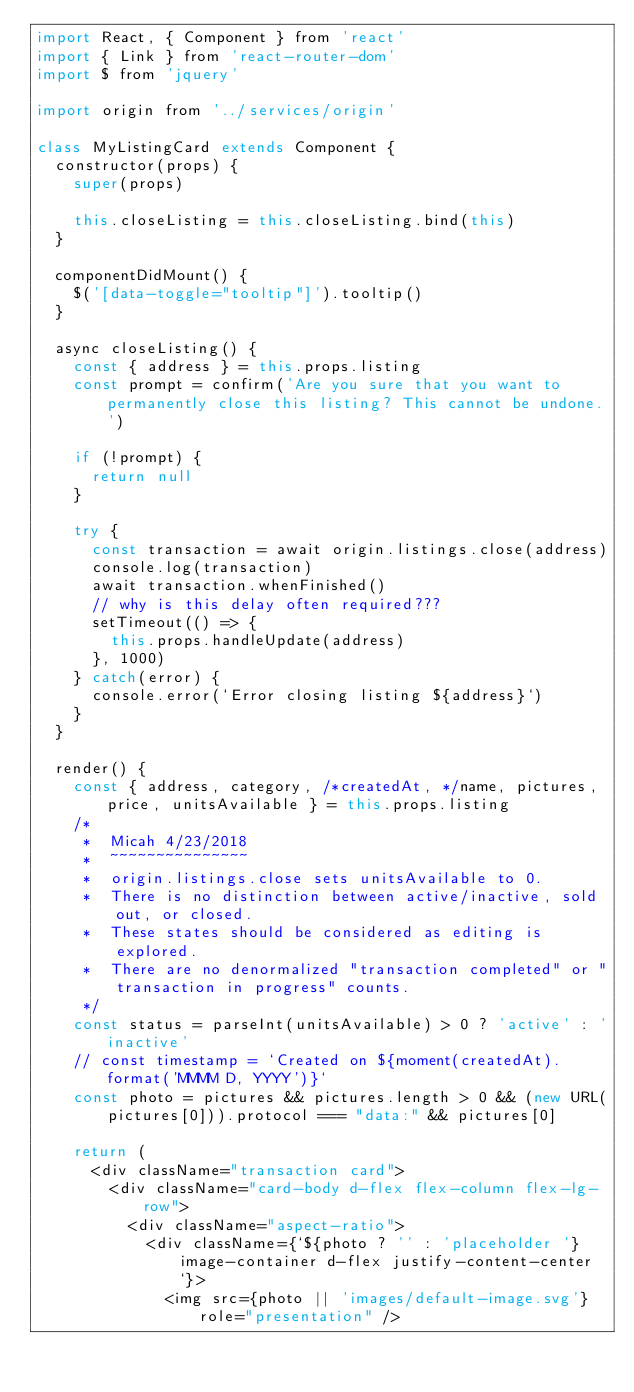Convert code to text. <code><loc_0><loc_0><loc_500><loc_500><_JavaScript_>import React, { Component } from 'react'
import { Link } from 'react-router-dom'
import $ from 'jquery'

import origin from '../services/origin'

class MyListingCard extends Component {
  constructor(props) {
    super(props)

    this.closeListing = this.closeListing.bind(this)
  }

  componentDidMount() {
    $('[data-toggle="tooltip"]').tooltip()
  }

  async closeListing() {
    const { address } = this.props.listing
    const prompt = confirm('Are you sure that you want to permanently close this listing? This cannot be undone.')

    if (!prompt) {
      return null
    }

    try {
      const transaction = await origin.listings.close(address)
      console.log(transaction)
      await transaction.whenFinished()
      // why is this delay often required???
      setTimeout(() => {
        this.props.handleUpdate(address)
      }, 1000)
    } catch(error) {
      console.error(`Error closing listing ${address}`)
    }
  }

  render() {
    const { address, category, /*createdAt, */name, pictures, price, unitsAvailable } = this.props.listing
    /*
     *  Micah 4/23/2018
     *  ~~~~~~~~~~~~~~~
     *  origin.listings.close sets unitsAvailable to 0.
     *  There is no distinction between active/inactive, sold out, or closed.
     *  These states should be considered as editing is explored.
     *  There are no denormalized "transaction completed" or "transaction in progress" counts.
     */
    const status = parseInt(unitsAvailable) > 0 ? 'active' : 'inactive'
    // const timestamp = `Created on ${moment(createdAt).format('MMMM D, YYYY')}`
    const photo = pictures && pictures.length > 0 && (new URL(pictures[0])).protocol === "data:" && pictures[0]

    return (
      <div className="transaction card">
        <div className="card-body d-flex flex-column flex-lg-row">
          <div className="aspect-ratio">
            <div className={`${photo ? '' : 'placeholder '}image-container d-flex justify-content-center`}>
              <img src={photo || 'images/default-image.svg'} role="presentation" /></code> 